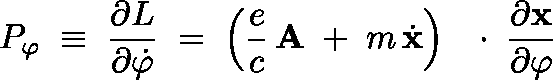<formula> <loc_0><loc_0><loc_500><loc_500>P _ { \varphi } \, \equiv \, \frac { \partial L } { \partial \dot { \varphi } } \, = \, \left ( \frac { e } { c } \, { A } \, + \, m \, \dot { x } \right ) \, \boldmath \cdot \, \frac { \partial x } { \partial \varphi }</formula> 